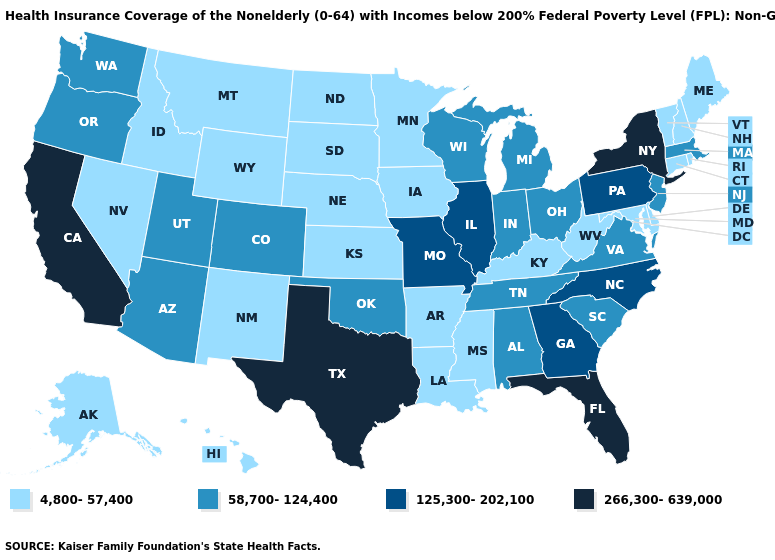Name the states that have a value in the range 4,800-57,400?
Short answer required. Alaska, Arkansas, Connecticut, Delaware, Hawaii, Idaho, Iowa, Kansas, Kentucky, Louisiana, Maine, Maryland, Minnesota, Mississippi, Montana, Nebraska, Nevada, New Hampshire, New Mexico, North Dakota, Rhode Island, South Dakota, Vermont, West Virginia, Wyoming. What is the value of California?
Write a very short answer. 266,300-639,000. What is the highest value in the USA?
Concise answer only. 266,300-639,000. Does the first symbol in the legend represent the smallest category?
Write a very short answer. Yes. What is the lowest value in the USA?
Answer briefly. 4,800-57,400. Name the states that have a value in the range 4,800-57,400?
Concise answer only. Alaska, Arkansas, Connecticut, Delaware, Hawaii, Idaho, Iowa, Kansas, Kentucky, Louisiana, Maine, Maryland, Minnesota, Mississippi, Montana, Nebraska, Nevada, New Hampshire, New Mexico, North Dakota, Rhode Island, South Dakota, Vermont, West Virginia, Wyoming. Does Florida have the highest value in the USA?
Quick response, please. Yes. Which states have the highest value in the USA?
Be succinct. California, Florida, New York, Texas. Name the states that have a value in the range 58,700-124,400?
Be succinct. Alabama, Arizona, Colorado, Indiana, Massachusetts, Michigan, New Jersey, Ohio, Oklahoma, Oregon, South Carolina, Tennessee, Utah, Virginia, Washington, Wisconsin. Which states hav the highest value in the Northeast?
Keep it brief. New York. Is the legend a continuous bar?
Write a very short answer. No. Does the map have missing data?
Answer briefly. No. Does New York have the highest value in the USA?
Concise answer only. Yes. Name the states that have a value in the range 125,300-202,100?
Short answer required. Georgia, Illinois, Missouri, North Carolina, Pennsylvania. Does Kentucky have the highest value in the USA?
Write a very short answer. No. 